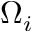Convert formula to latex. <formula><loc_0><loc_0><loc_500><loc_500>\Omega _ { i }</formula> 